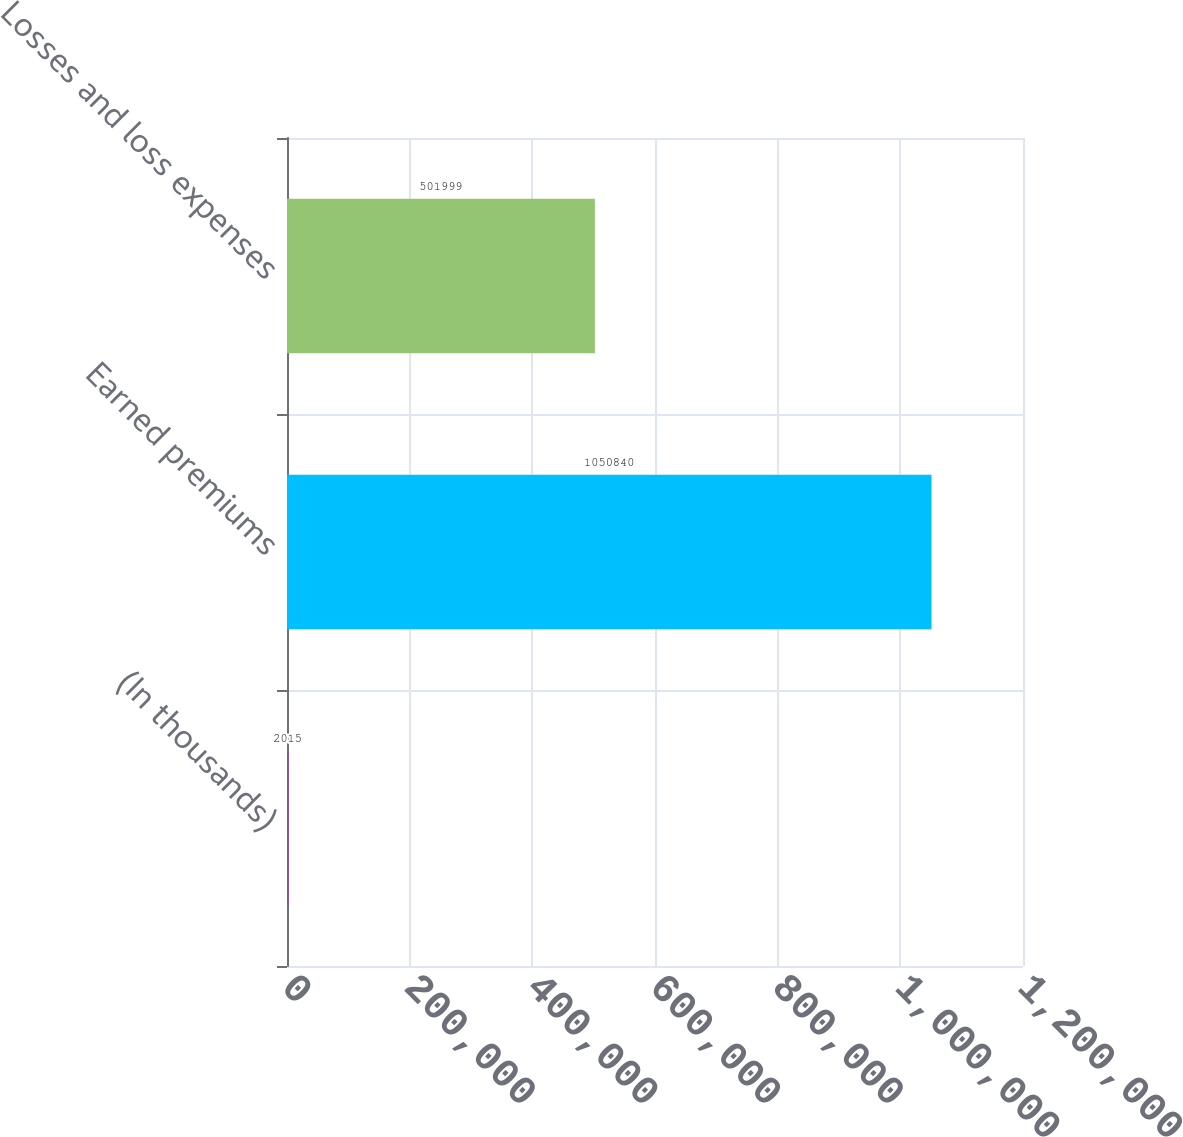<chart> <loc_0><loc_0><loc_500><loc_500><bar_chart><fcel>(In thousands)<fcel>Earned premiums<fcel>Losses and loss expenses<nl><fcel>2015<fcel>1.05084e+06<fcel>501999<nl></chart> 